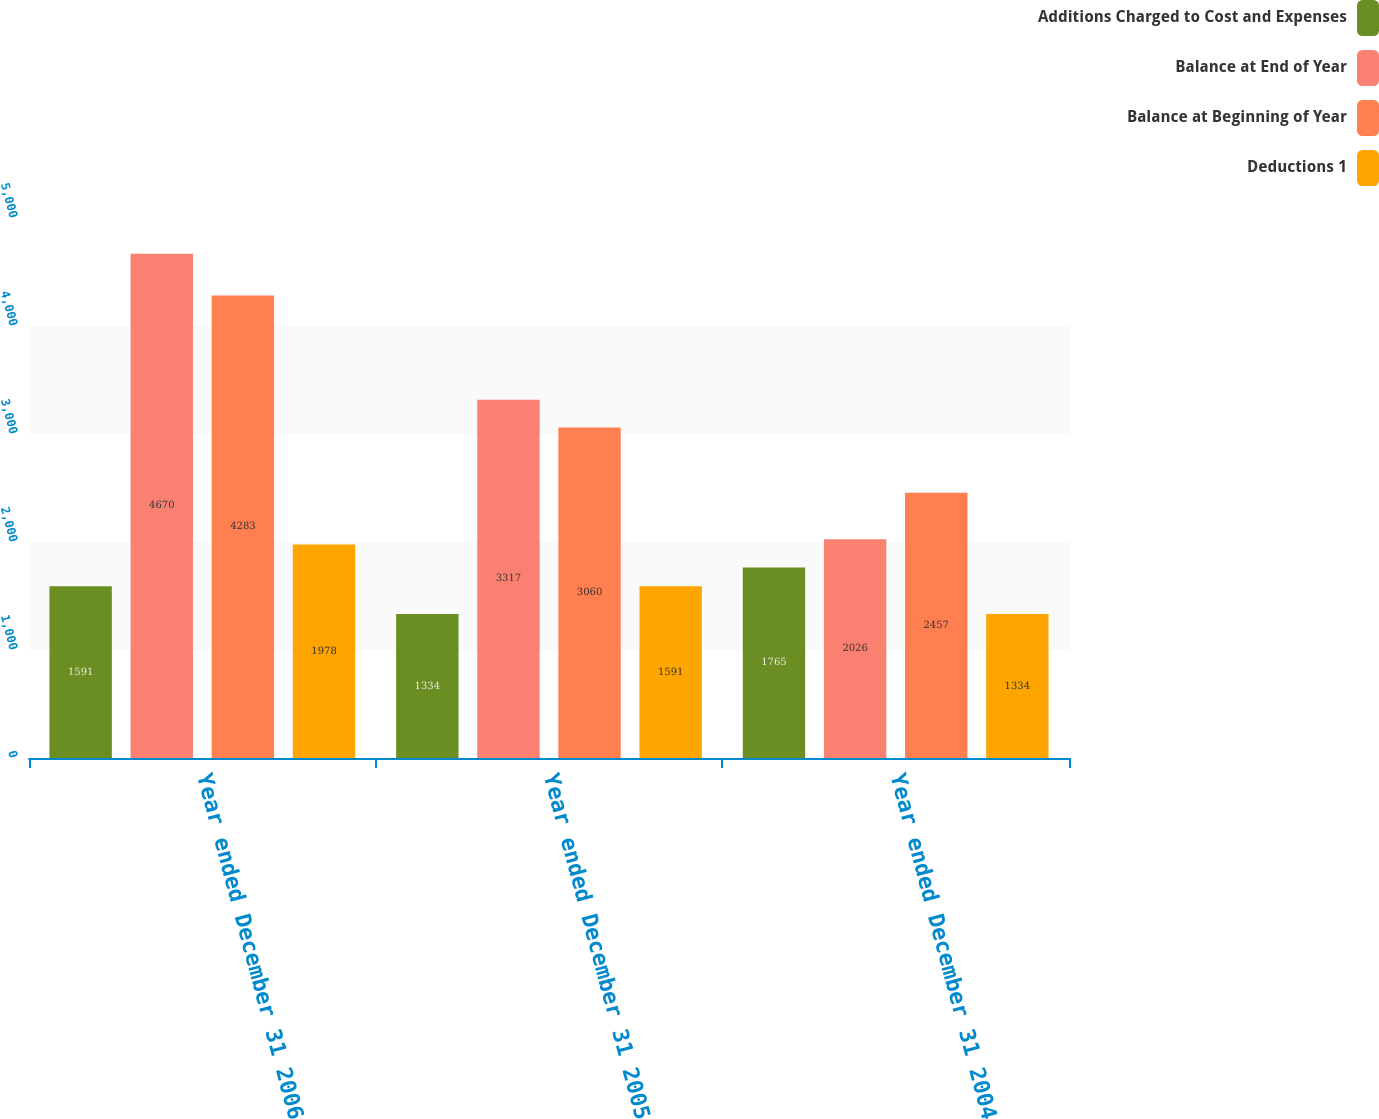Convert chart. <chart><loc_0><loc_0><loc_500><loc_500><stacked_bar_chart><ecel><fcel>Year ended December 31 2006<fcel>Year ended December 31 2005<fcel>Year ended December 31 2004<nl><fcel>Additions Charged to Cost and Expenses<fcel>1591<fcel>1334<fcel>1765<nl><fcel>Balance at End of Year<fcel>4670<fcel>3317<fcel>2026<nl><fcel>Balance at Beginning of Year<fcel>4283<fcel>3060<fcel>2457<nl><fcel>Deductions 1<fcel>1978<fcel>1591<fcel>1334<nl></chart> 